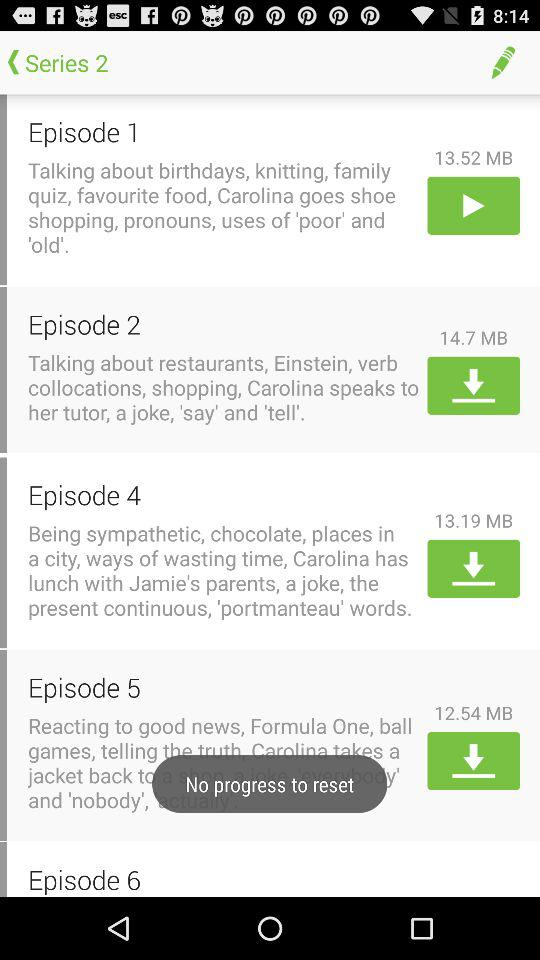What is episode 1 all about? Episode 1 is all about "Talking about birthdays, knitting, family quiz, favourite food, Carolina goes shoe shopping, pronouns, uses of 'poor' and 'old'.". 